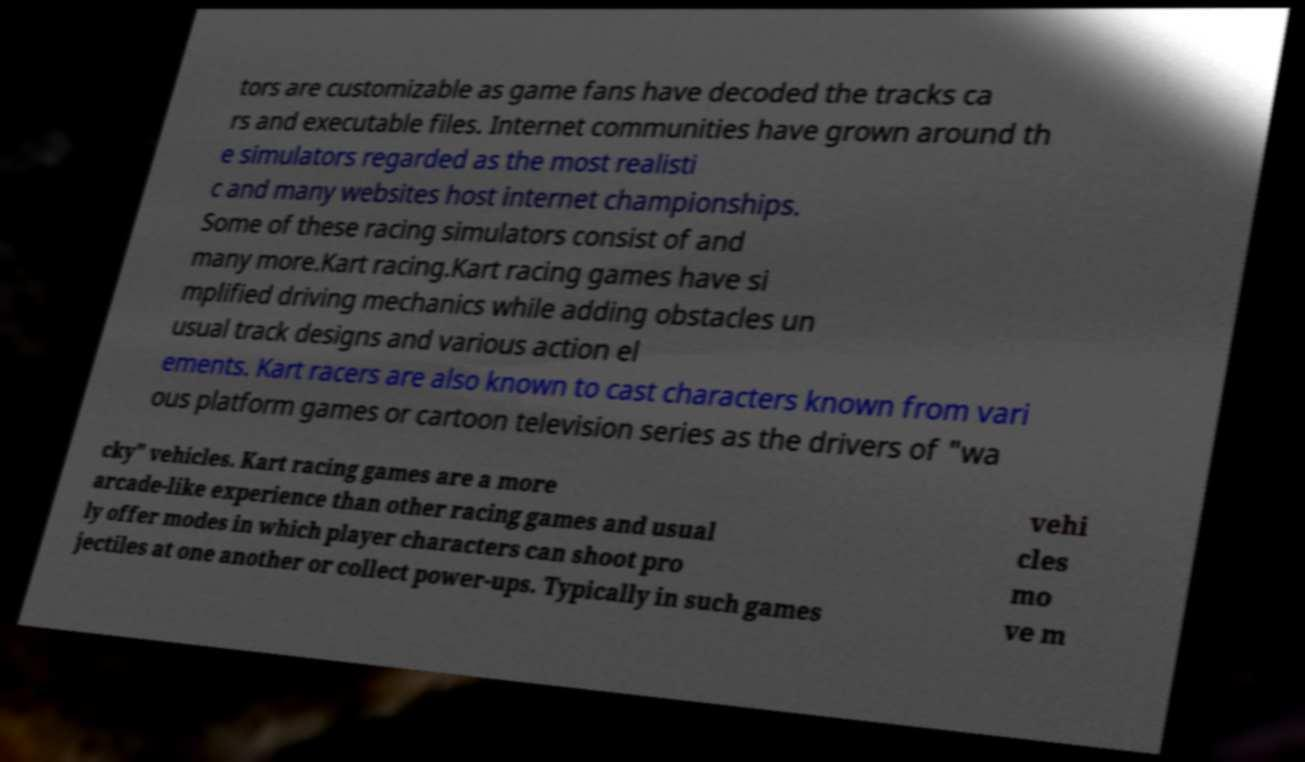What messages or text are displayed in this image? I need them in a readable, typed format. tors are customizable as game fans have decoded the tracks ca rs and executable files. Internet communities have grown around th e simulators regarded as the most realisti c and many websites host internet championships. Some of these racing simulators consist of and many more.Kart racing.Kart racing games have si mplified driving mechanics while adding obstacles un usual track designs and various action el ements. Kart racers are also known to cast characters known from vari ous platform games or cartoon television series as the drivers of "wa cky" vehicles. Kart racing games are a more arcade-like experience than other racing games and usual ly offer modes in which player characters can shoot pro jectiles at one another or collect power-ups. Typically in such games vehi cles mo ve m 